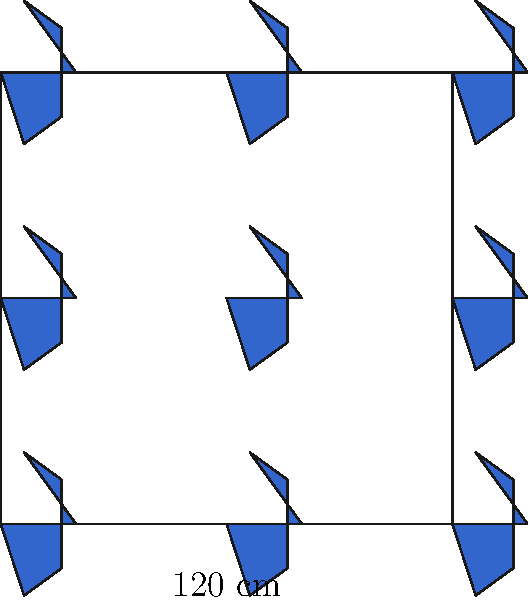A traditional Arabic tile pattern consists of interlocking six-pointed stars, as shown in the diagram. The pattern repeats in a square grid, with each square measuring 120 cm on each side. If the area of one complete star is 1200 cm², what is the total area covered by the stars in a 3x3 grid of these squares? To solve this problem, let's break it down into steps:

1) First, we need to determine how many complete stars are in the 3x3 grid:
   - Each square contains 1 complete star at its center.
   - There are 9 squares in a 3x3 grid.
   - Therefore, there are 9 complete stars.

2) We're given that the area of one complete star is 1200 cm².

3) To find the total area covered by the stars:
   $$\text{Total Area} = \text{Number of stars} \times \text{Area of one star}$$
   $$\text{Total Area} = 9 \times 1200 \text{ cm}^2$$
   $$\text{Total Area} = 10800 \text{ cm}^2$$

4) However, this is not our final answer. Notice that the stars at the edges of the grid are partially cut off. These partial stars contribute additional area.

5) In the 3x3 grid:
   - There are 12 half-stars along the edges (4 on each side of the square).
   - There are 4 quarter-stars at the corners.

6) The additional area from these partial stars:
   $$\text{Additional Area} = (12 \times \frac{1}{2} + 4 \times \frac{1}{4}) \times 1200 \text{ cm}^2$$
   $$\text{Additional Area} = (6 + 1) \times 1200 \text{ cm}^2 = 8400 \text{ cm}^2$$

7) Therefore, the total area covered by all star shapes (complete and partial) is:
   $$\text{Total Area} = 10800 \text{ cm}^2 + 8400 \text{ cm}^2 = 19200 \text{ cm}^2$$
Answer: 19200 cm² 